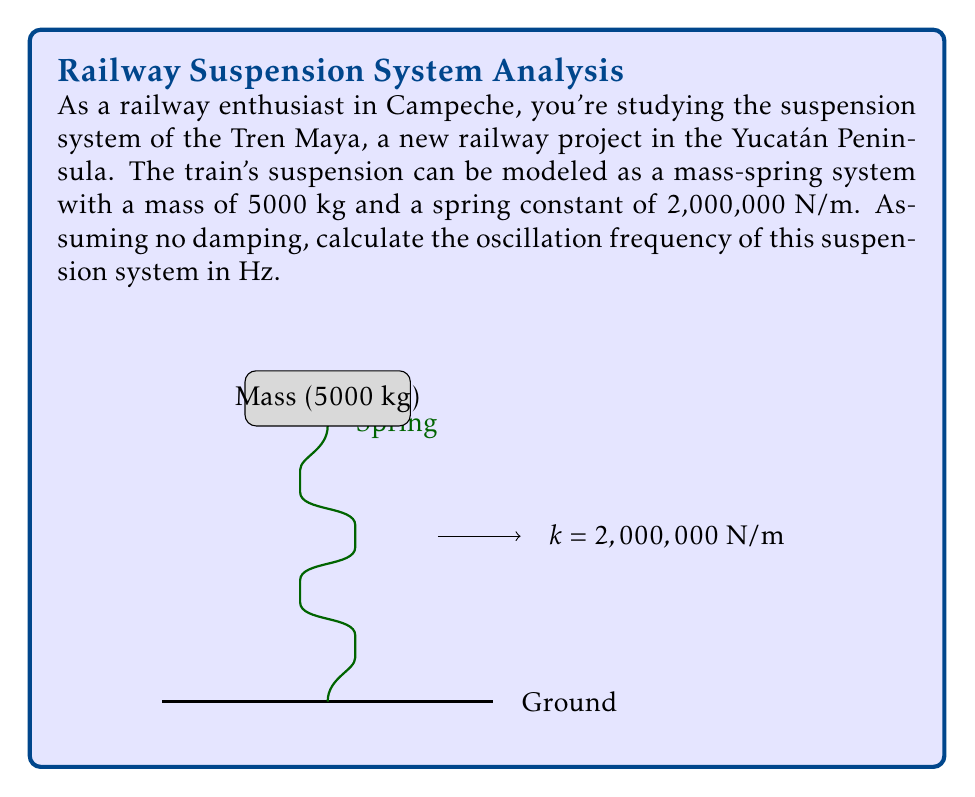Could you help me with this problem? To solve this problem, we'll use the formula for the natural frequency of a simple harmonic oscillator:

$$f = \frac{1}{2\pi} \sqrt{\frac{k}{m}}$$

Where:
$f$ is the frequency in Hz
$k$ is the spring constant in N/m
$m$ is the mass in kg

Given:
$k = 2,000,000$ N/m
$m = 5000$ kg

Let's substitute these values into the equation:

$$f = \frac{1}{2\pi} \sqrt{\frac{2,000,000}{5000}}$$

Simplify inside the square root:

$$f = \frac{1}{2\pi} \sqrt{400}$$

Calculate the square root:

$$f = \frac{1}{2\pi} \cdot 20$$

Simplify:

$$f = \frac{10}{\pi}$$

Using a calculator or approximating $\pi$:

$$f \approx 3.18 \text{ Hz}$$

Therefore, the oscillation frequency of the train suspension system is approximately 3.18 Hz.
Answer: $3.18 \text{ Hz}$ 